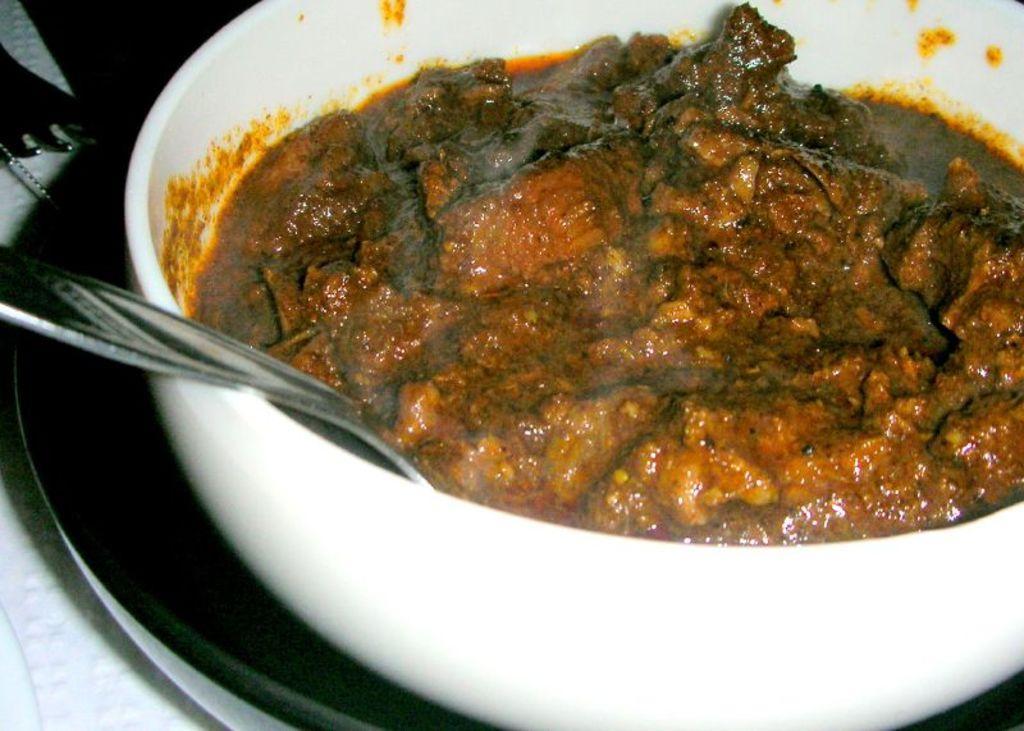In one or two sentences, can you explain what this image depicts? In this picture we can see a table. On the table we can see fork, cloth, plate and a bowl which contains food item with spoon. 